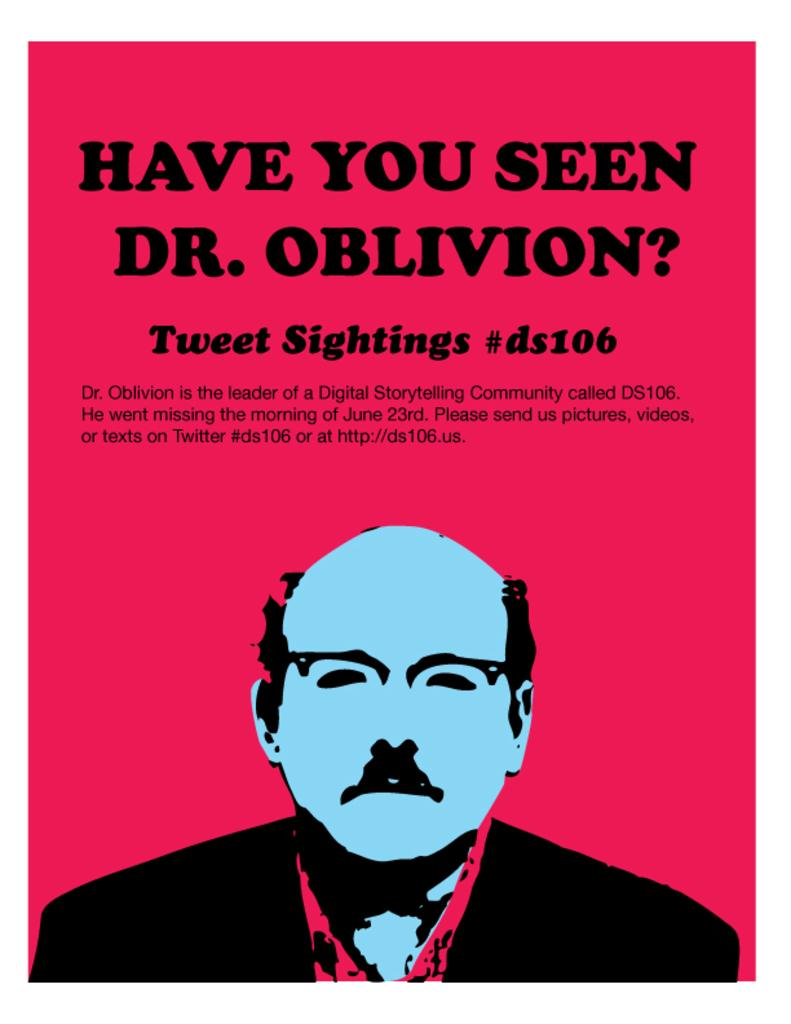<image>
Describe the image concisely. A poster asking for information on a missing man called Dr. Oblivion. 